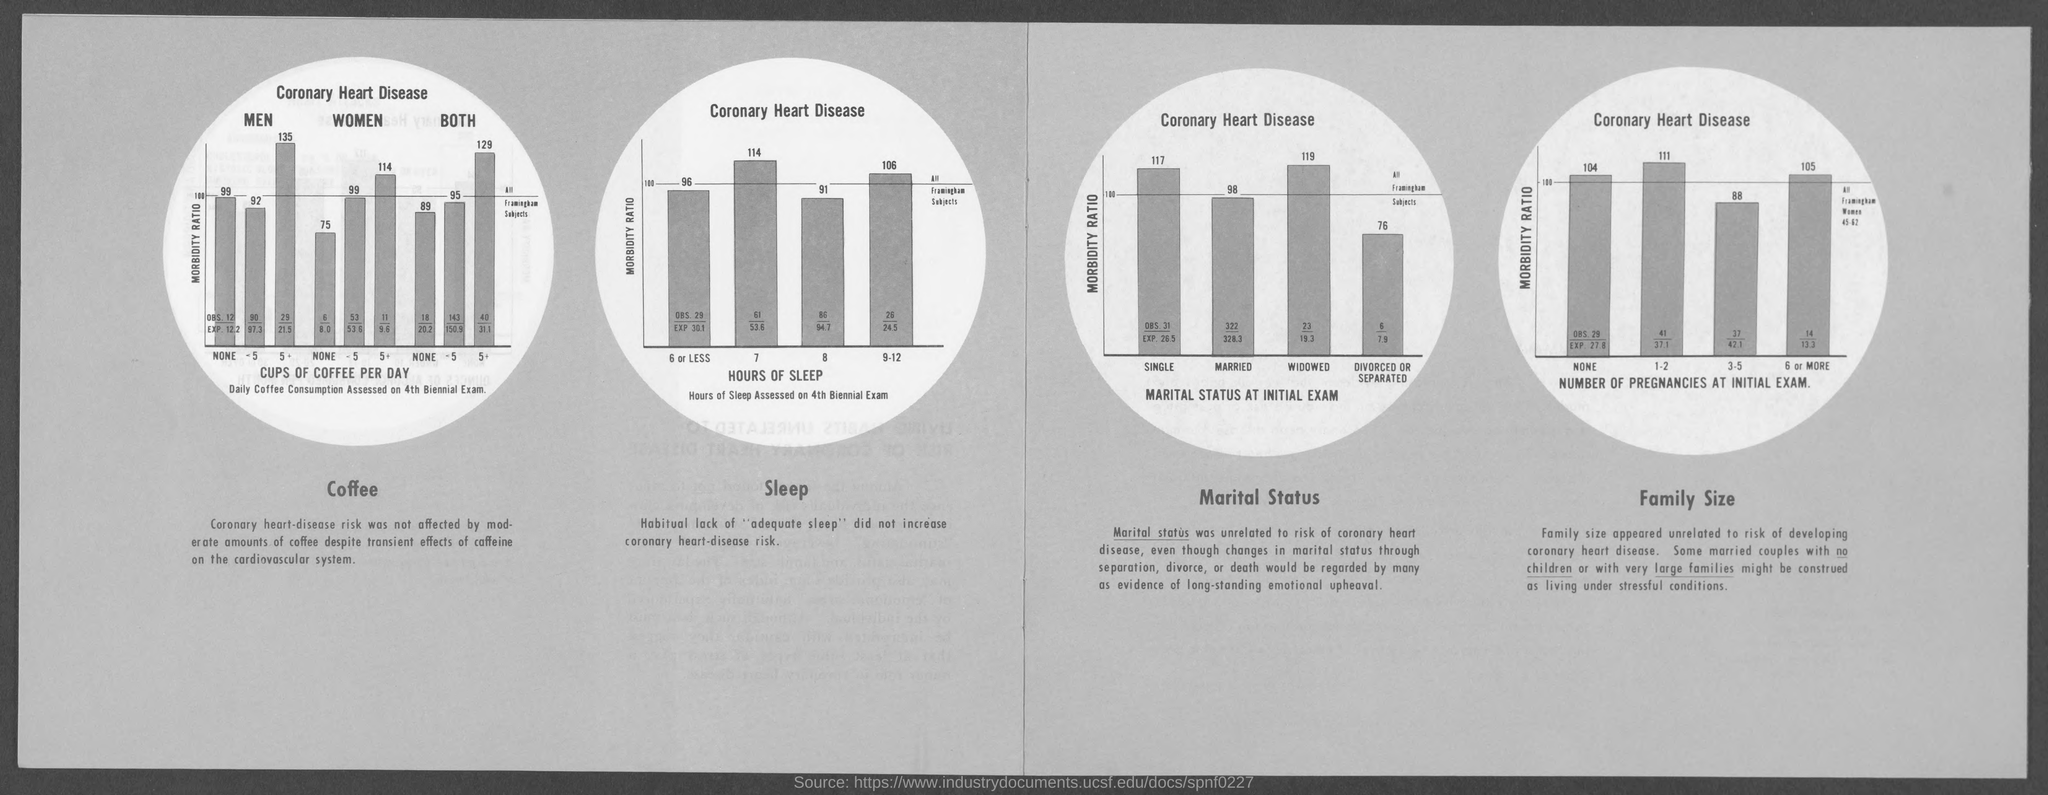What is on the X axis of first bar chart ?
Your answer should be very brief. CUPS OF COFFEE PER DAY Daily Coffee Consumption Assessed on 4th Biennial Exam. What is on the X axis of second bar chart ?
Your response must be concise. HOURS OF SLEEP. What is on the X axis of third bar chart ?
Your answer should be compact. MARITAL STATUS AT INITIAL EXAM. What is on the X axis of fourth bar chart ?
Offer a terse response. NUMBER OF PREGNANCIES AT INITIAL EXAM. 